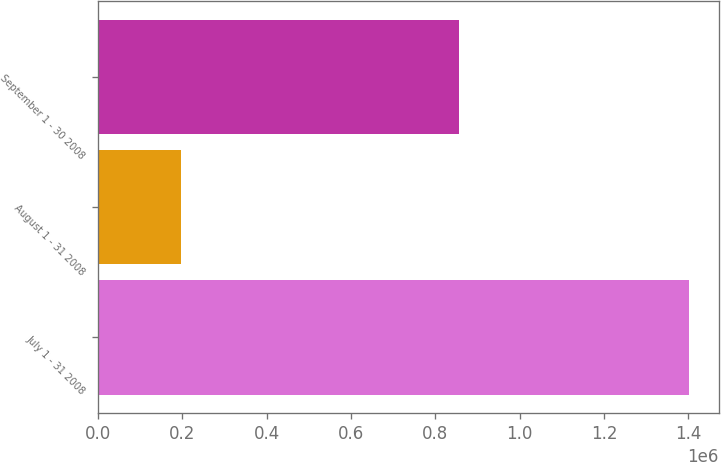<chart> <loc_0><loc_0><loc_500><loc_500><bar_chart><fcel>July 1 - 31 2008<fcel>August 1 - 31 2008<fcel>September 1 - 30 2008<nl><fcel>1.40176e+06<fcel>195800<fcel>855700<nl></chart> 